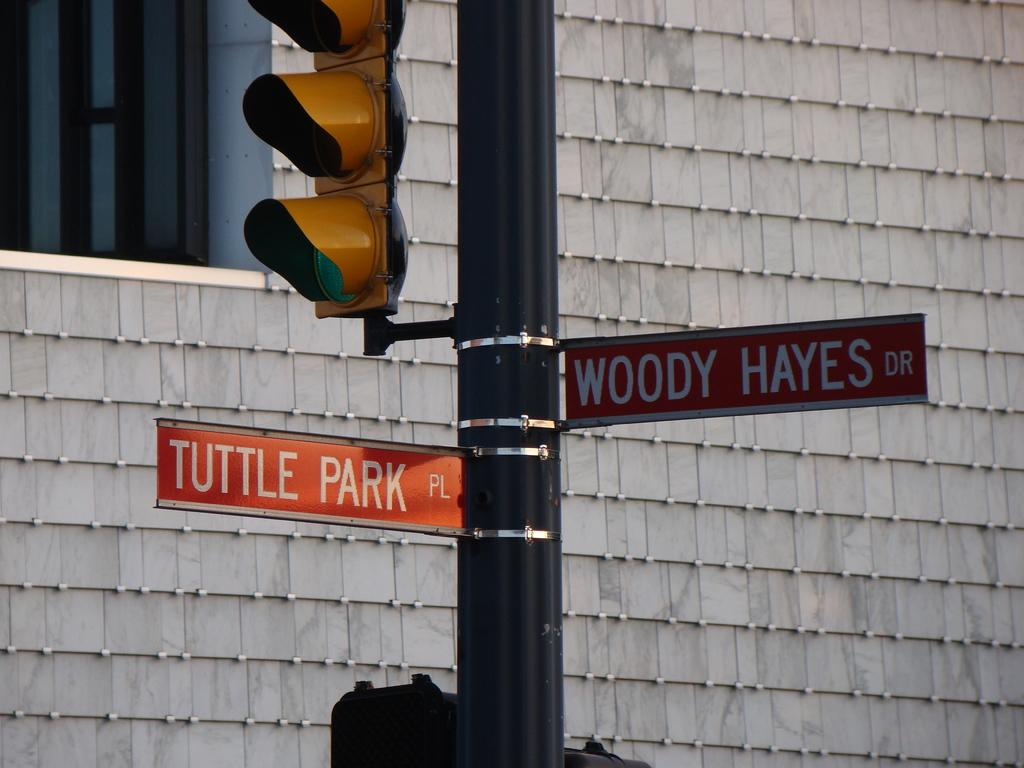<image>
Provide a brief description of the given image. An intersection of Tuttle Park Pl. and Woody Hayes Dr. 